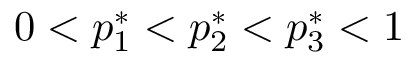<formula> <loc_0><loc_0><loc_500><loc_500>0 < p _ { 1 } ^ { * } < p _ { 2 } ^ { * } < p _ { 3 } ^ { * } < 1</formula> 